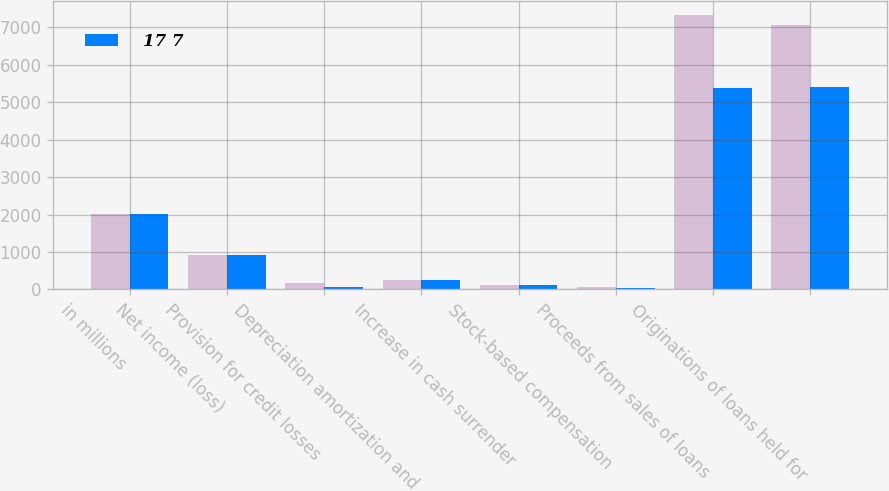<chart> <loc_0><loc_0><loc_500><loc_500><stacked_bar_chart><ecel><fcel>in millions<fcel>Net income (loss)<fcel>Provision for credit losses<fcel>Depreciation amortization and<fcel>Increase in cash surrender<fcel>Stock-based compensation<fcel>Proceeds from sales of loans<fcel>Originations of loans held for<nl><fcel>nan<fcel>2015<fcel>920<fcel>166<fcel>247<fcel>108<fcel>58<fcel>7333<fcel>7072<nl><fcel>17 7<fcel>2014<fcel>907<fcel>57<fcel>246<fcel>106<fcel>44<fcel>5386<fcel>5415<nl></chart> 